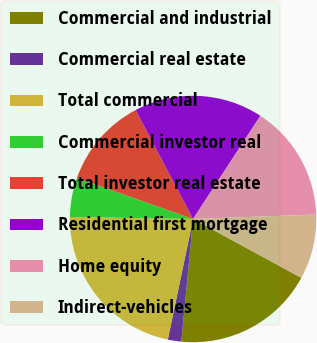Convert chart to OTSL. <chart><loc_0><loc_0><loc_500><loc_500><pie_chart><fcel>Commercial and industrial<fcel>Commercial real estate<fcel>Total commercial<fcel>Commercial investor real<fcel>Total investor real estate<fcel>Residential first mortgage<fcel>Home equity<fcel>Indirect-vehicles<nl><fcel>18.6%<fcel>1.77%<fcel>21.97%<fcel>5.14%<fcel>11.87%<fcel>16.92%<fcel>15.23%<fcel>8.5%<nl></chart> 